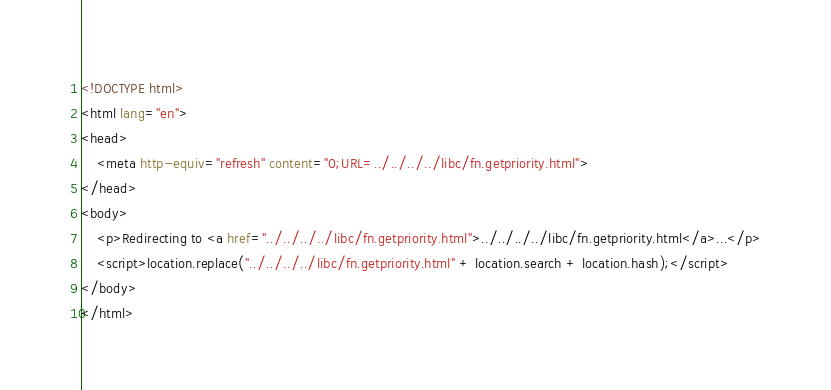<code> <loc_0><loc_0><loc_500><loc_500><_HTML_><!DOCTYPE html>
<html lang="en">
<head>
    <meta http-equiv="refresh" content="0;URL=../../../../libc/fn.getpriority.html">
</head>
<body>
    <p>Redirecting to <a href="../../../../libc/fn.getpriority.html">../../../../libc/fn.getpriority.html</a>...</p>
    <script>location.replace("../../../../libc/fn.getpriority.html" + location.search + location.hash);</script>
</body>
</html></code> 